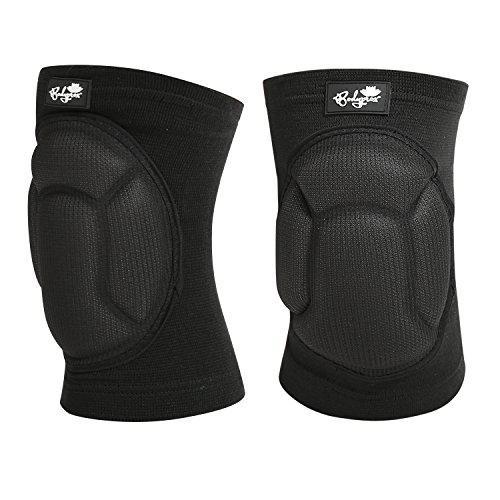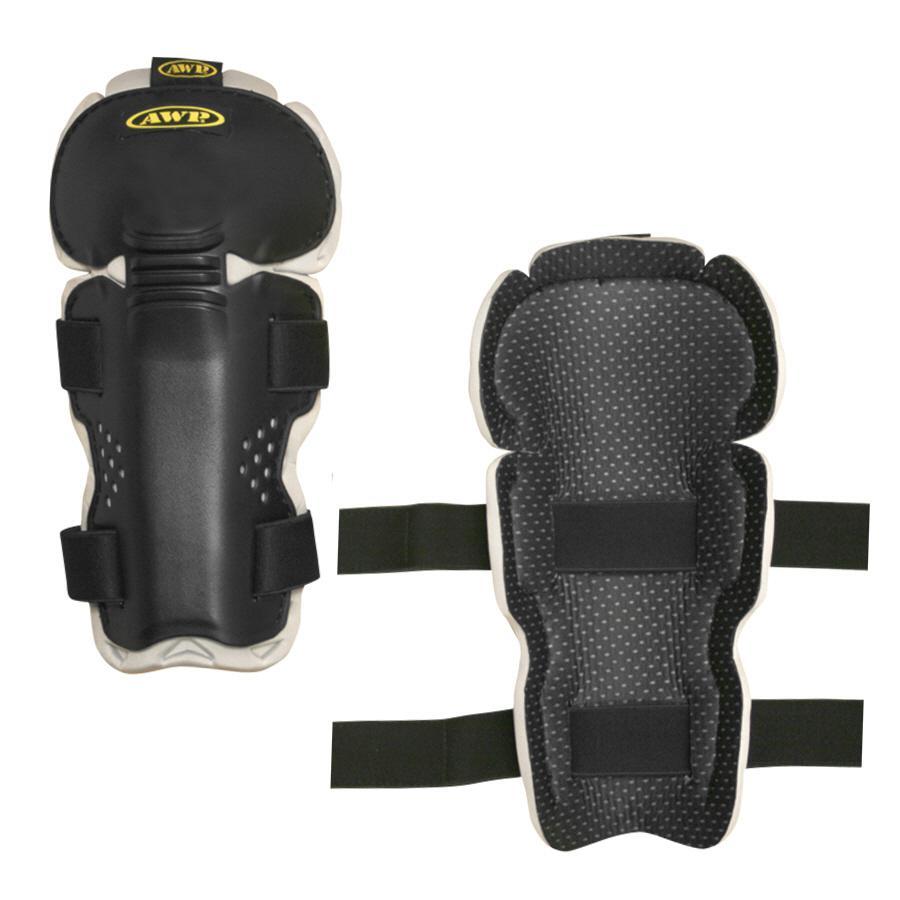The first image is the image on the left, the second image is the image on the right. For the images shown, is this caption "There are two pairs of unworn knee pads" true? Answer yes or no. Yes. The first image is the image on the left, the second image is the image on the right. Analyze the images presented: Is the assertion "Each image shows a pair of unworn knee pads." valid? Answer yes or no. Yes. 